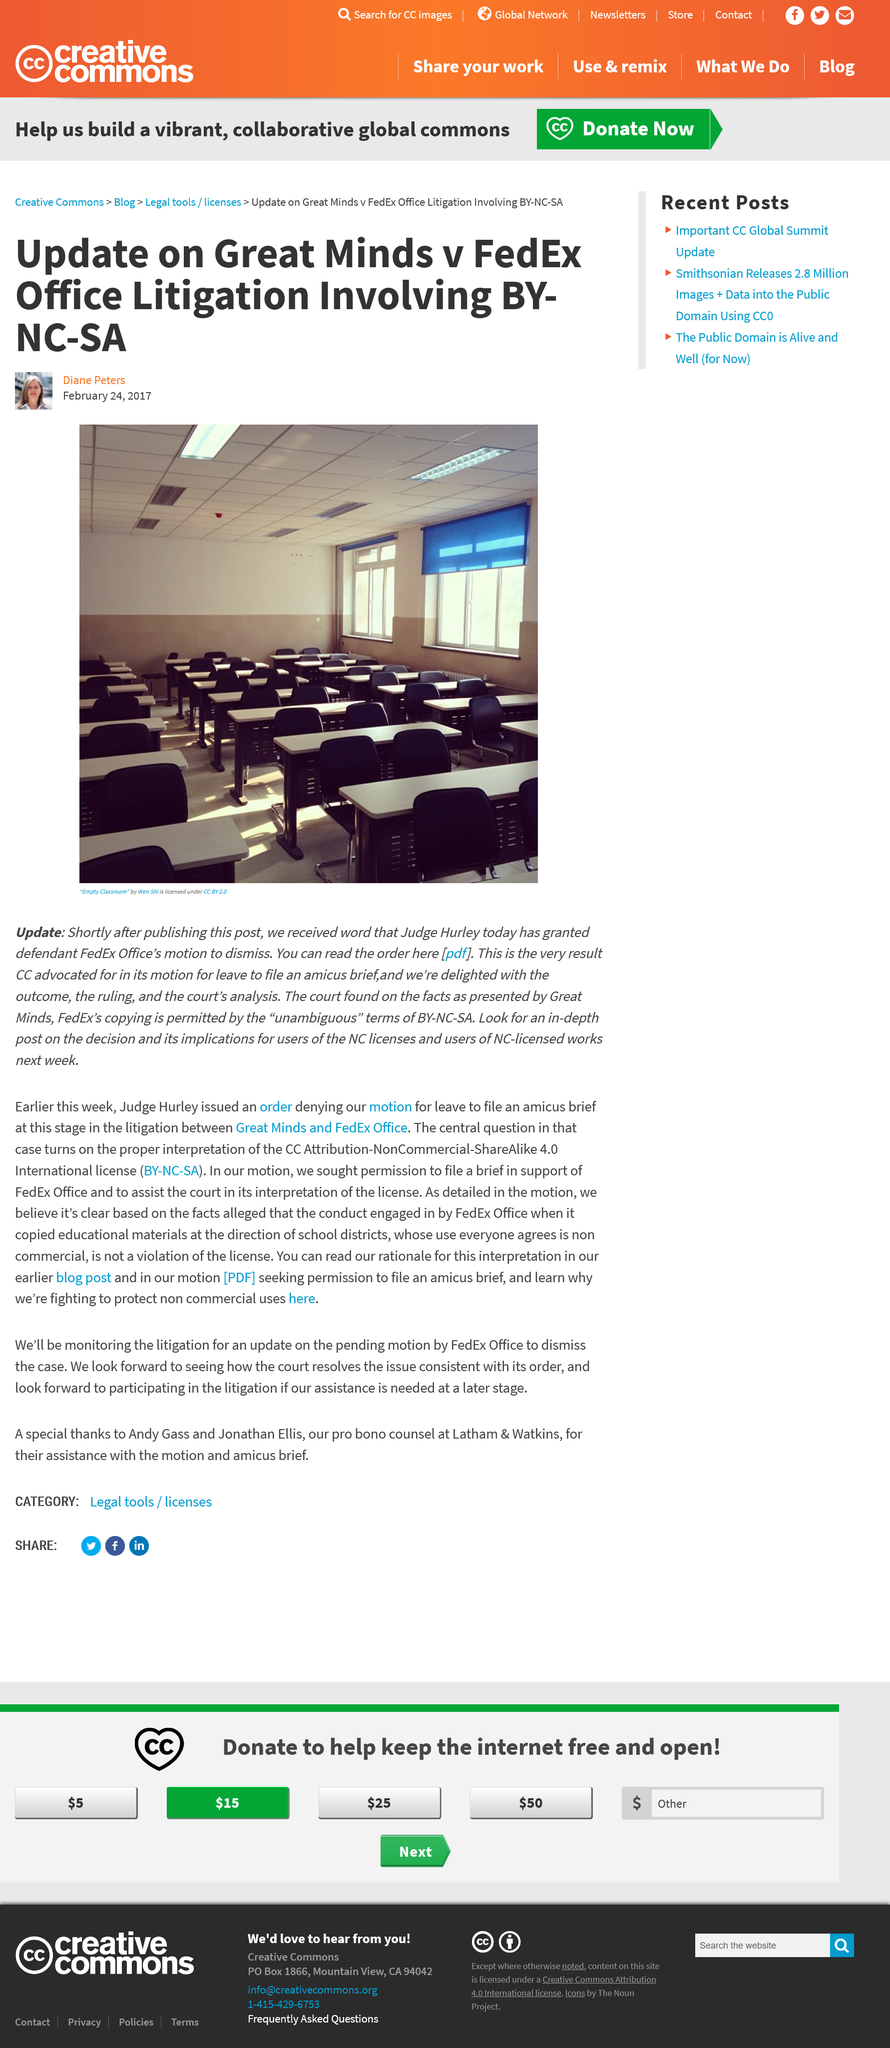Draw attention to some important aspects in this diagram. The judge's name is Hurley. The Plaintiff company is named Great Minds. The defendant company's name is FedEx Office. 